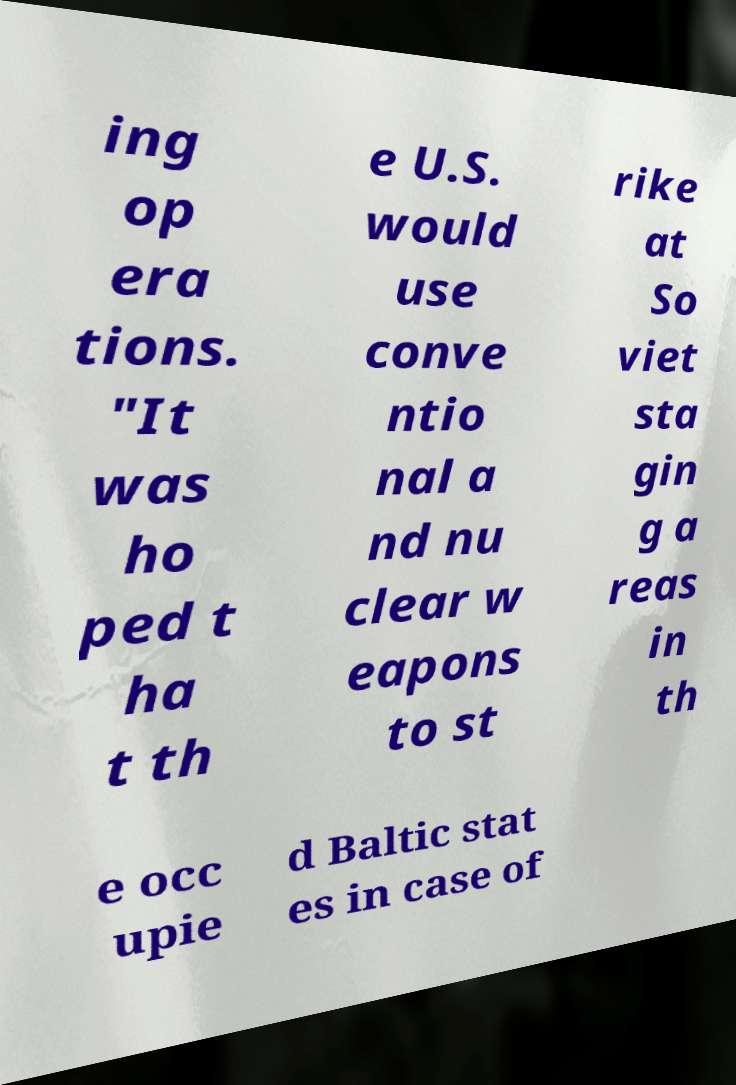Can you read and provide the text displayed in the image?This photo seems to have some interesting text. Can you extract and type it out for me? ing op era tions. "It was ho ped t ha t th e U.S. would use conve ntio nal a nd nu clear w eapons to st rike at So viet sta gin g a reas in th e occ upie d Baltic stat es in case of 